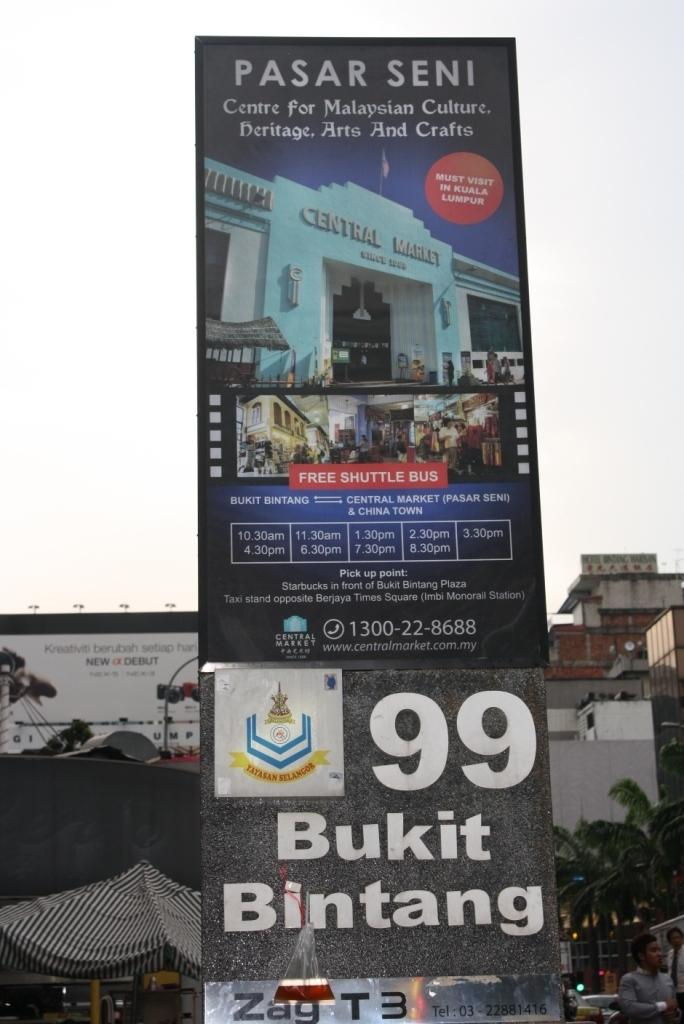<image>
Relay a brief, clear account of the picture shown. A rectangular outdoor billboard with a Pasar Seni advert on it. 